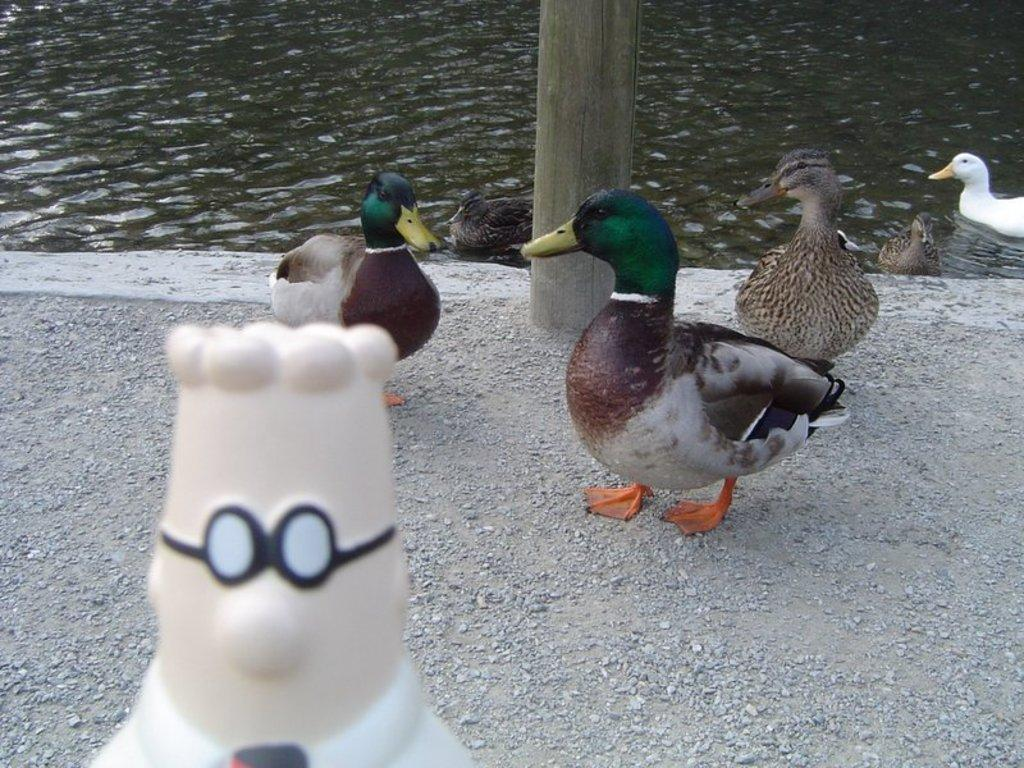What is the main object in the foreground of the image? There is a white color toy in the foreground of the image. What type of animals are present in the foreground of the image? There are ducks on the ground in the foreground. What are the ducks doing in the image? Some ducks are swimming in the water. What structure can be seen in the image? There is a wooden pole visible in the image. What type of shirt is the duck wearing in the image? Ducks do not wear shirts, and there are no shirts present in the image. Can you tell me how many cushions are on the wooden pole in the image? There are no cushions present in the image, and the wooden pole does not have any cushions on it. 